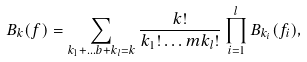Convert formula to latex. <formula><loc_0><loc_0><loc_500><loc_500>B _ { k } ( f ) = \sum _ { k _ { 1 } + \dots b + k _ { l } = k } \frac { k ! } { k _ { 1 } ! \dots m k _ { l } ! } \prod _ { i = 1 } ^ { l } B _ { k _ { i } } ( f _ { i } ) ,</formula> 